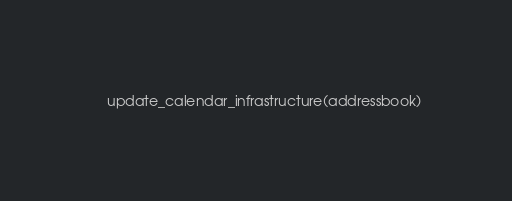Convert code to text. <code><loc_0><loc_0><loc_500><loc_500><_Python_>    update_calendar_infrastructure(addressbook)
</code> 